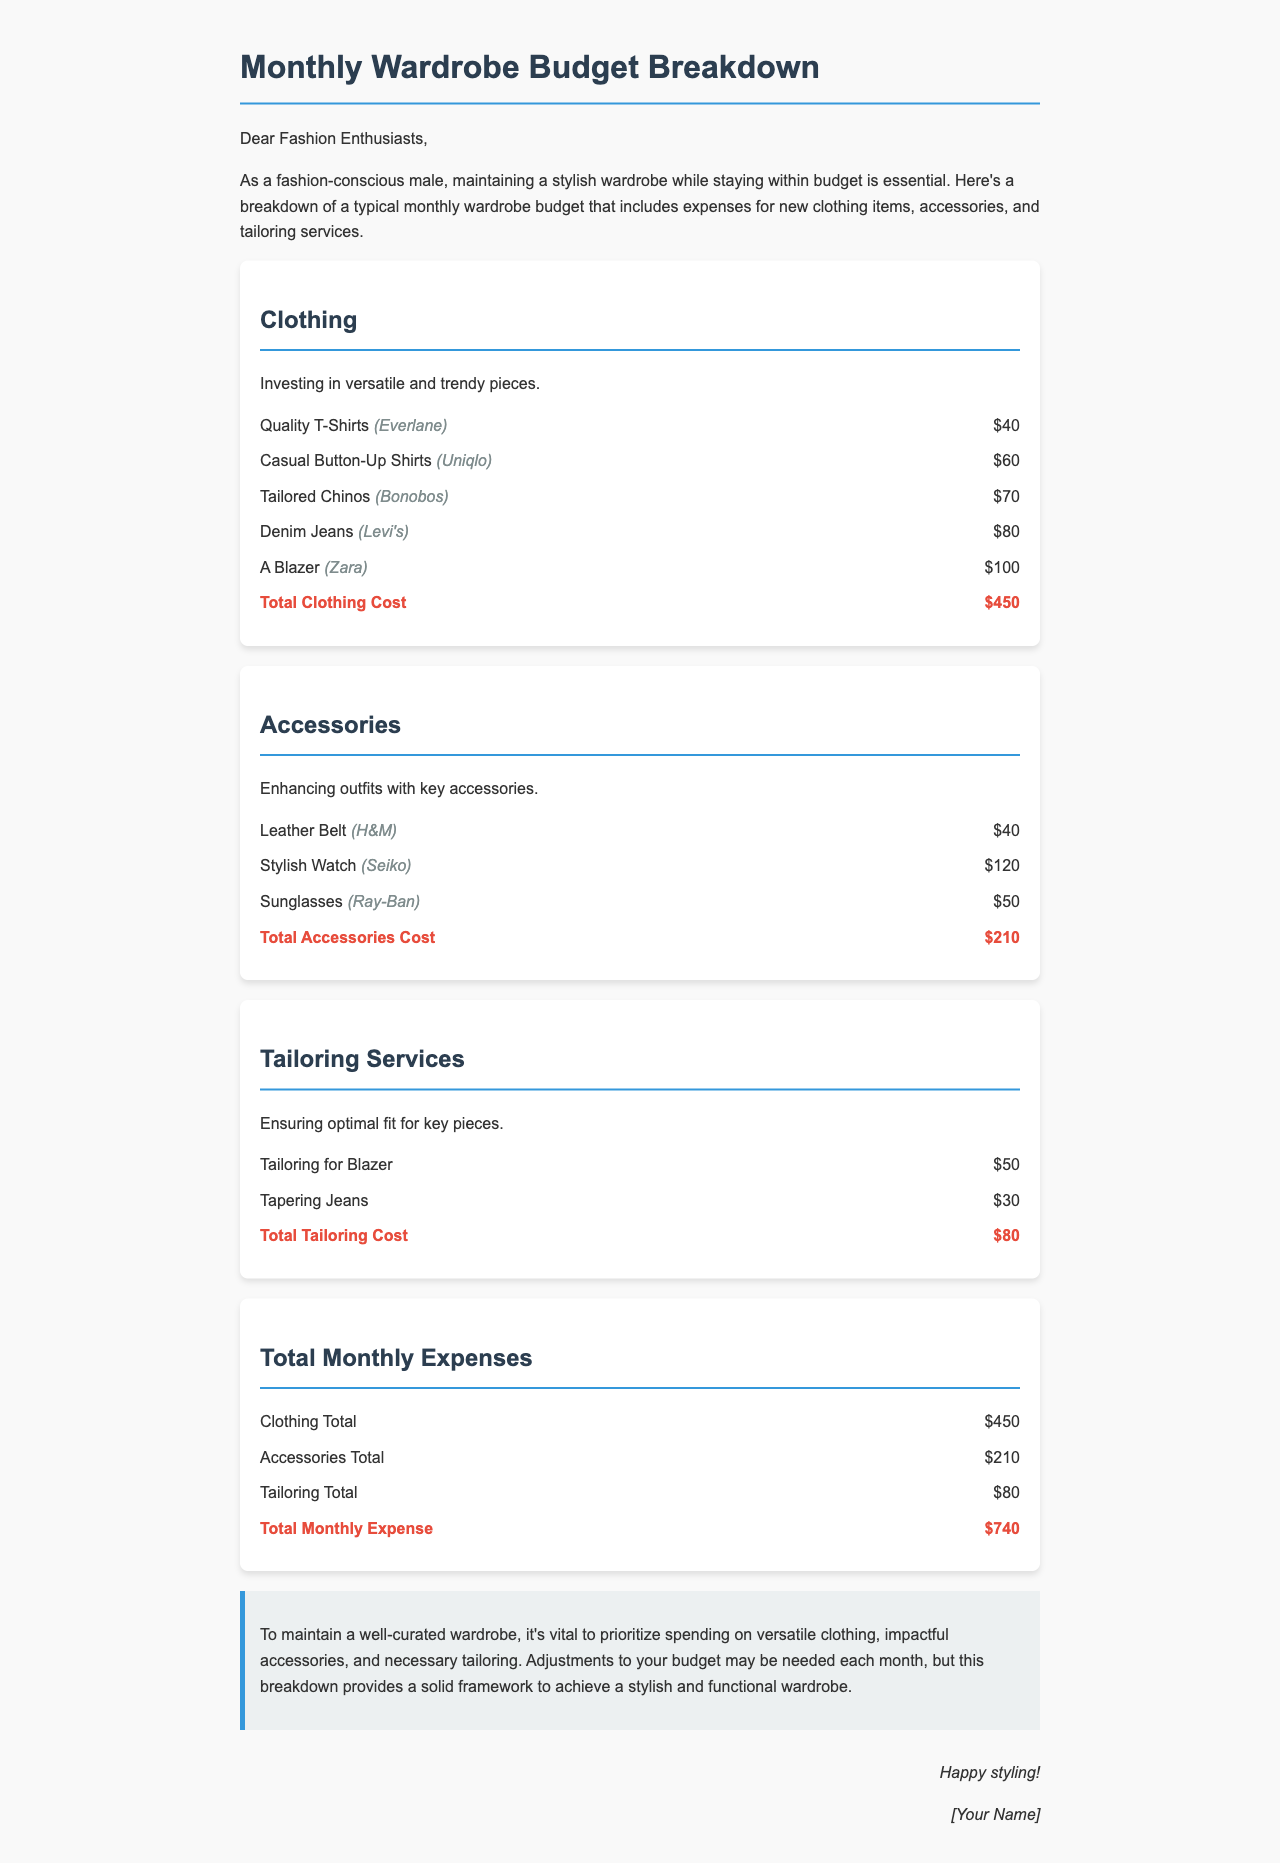what is the total clothing cost? The total clothing cost is clearly stated at the end of the clothing section of the document, which is $450.
Answer: $450 how much is spent on accessories? The total accessories cost is mentioned at the end of the accessories section, which is $210.
Answer: $210 what is the total monthly expense? The total monthly expense is provided in the summary section of the document, which adds up to $740.
Answer: $740 what is one brand of the clothing items mentioned? The document lists various clothing items along with their respective brands, one example is Everlane for Quality T-Shirts.
Answer: Everlane how many tailoring services are included in the breakdown? The document lists two tailoring services: Tailoring for Blazer and Tapering Jeans, making it a total of 2.
Answer: 2 which clothing item from Zara is mentioned? The document specifically mentions a Blazer from Zara in the clothing section.
Answer: Blazer what type of accessory is the stylish watch classified as? The stylish watch is categorized under the accessories section of the document, highlighting it as a key accessory.
Answer: accessory who is the letter addressed to? The letter begins with "Dear Fashion Enthusiasts," indicating the audience is fashion-conscious individuals.
Answer: Fashion Enthusiasts 